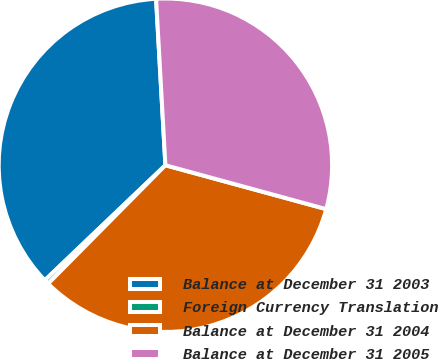<chart> <loc_0><loc_0><loc_500><loc_500><pie_chart><fcel>Balance at December 31 2003<fcel>Foreign Currency Translation<fcel>Balance at December 31 2004<fcel>Balance at December 31 2005<nl><fcel>36.24%<fcel>0.45%<fcel>33.18%<fcel>30.13%<nl></chart> 